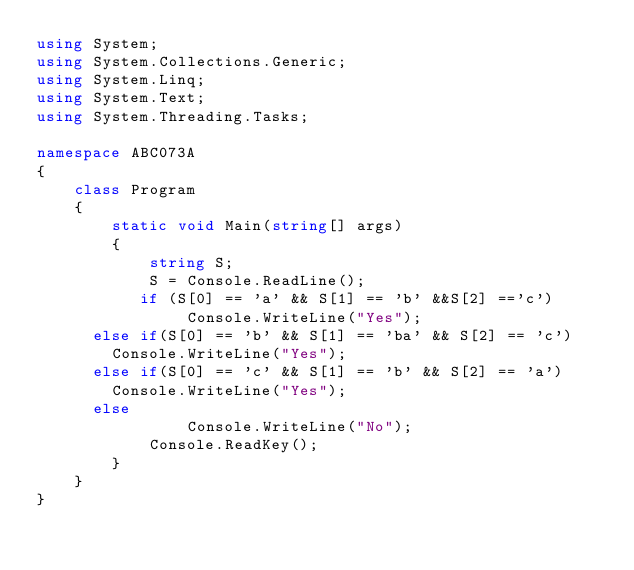<code> <loc_0><loc_0><loc_500><loc_500><_C#_>using System;
using System.Collections.Generic;
using System.Linq;
using System.Text;
using System.Threading.Tasks;

namespace ABC073A
{
    class Program
    {
        static void Main(string[] args)
        {
            string S;
            S = Console.ReadLine();
           if (S[0] == 'a' && S[1] == 'b' &&S[2] =='c')
                Console.WriteLine("Yes");
			else if(S[0] == 'b' && S[1] == 'ba' && S[2] == 'c')
				Console.WriteLine("Yes");
			else if(S[0] == 'c' && S[1] == 'b' && S[2] == 'a')
				Console.WriteLine("Yes");
			else
                Console.WriteLine("No");
            Console.ReadKey();
        }
    }
}</code> 